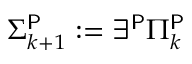<formula> <loc_0><loc_0><loc_500><loc_500>\Sigma _ { k + 1 } ^ { P } \colon = \exists ^ { P } \Pi _ { k } ^ { P }</formula> 